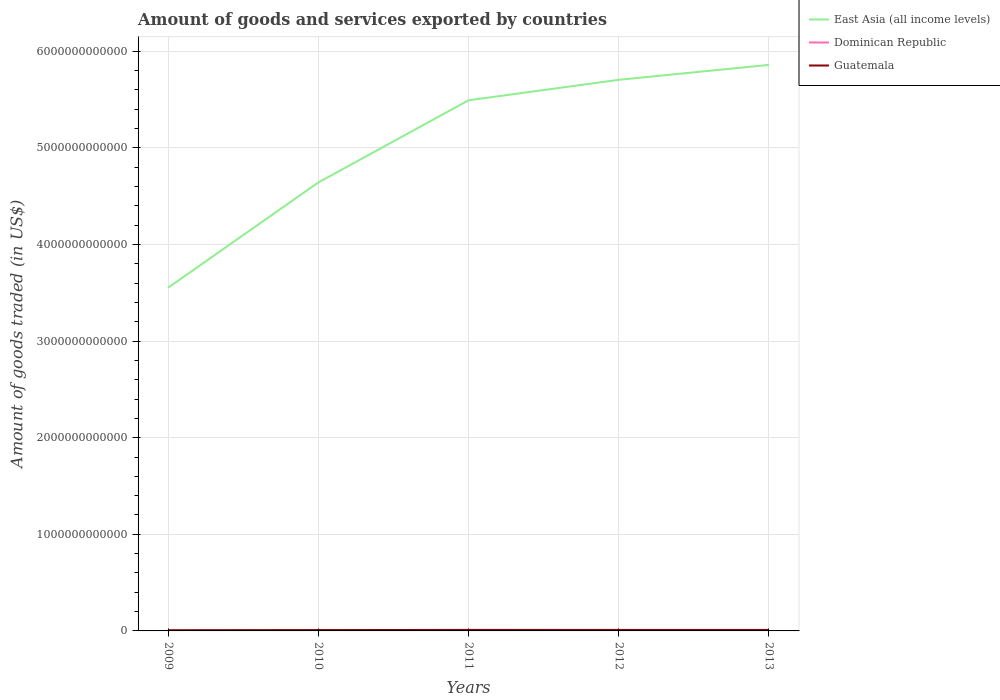Is the number of lines equal to the number of legend labels?
Your answer should be very brief. Yes. Across all years, what is the maximum total amount of goods and services exported in Guatemala?
Ensure brevity in your answer.  7.29e+09. What is the total total amount of goods and services exported in East Asia (all income levels) in the graph?
Keep it short and to the point. -2.31e+12. What is the difference between the highest and the second highest total amount of goods and services exported in East Asia (all income levels)?
Keep it short and to the point. 2.31e+12. How many lines are there?
Offer a terse response. 3. What is the difference between two consecutive major ticks on the Y-axis?
Your response must be concise. 1.00e+12. Does the graph contain grids?
Provide a succinct answer. Yes. How many legend labels are there?
Offer a terse response. 3. What is the title of the graph?
Provide a succinct answer. Amount of goods and services exported by countries. What is the label or title of the X-axis?
Ensure brevity in your answer.  Years. What is the label or title of the Y-axis?
Provide a short and direct response. Amount of goods traded (in US$). What is the Amount of goods traded (in US$) of East Asia (all income levels) in 2009?
Make the answer very short. 3.55e+12. What is the Amount of goods traded (in US$) of Dominican Republic in 2009?
Keep it short and to the point. 1.69e+09. What is the Amount of goods traded (in US$) of Guatemala in 2009?
Make the answer very short. 7.29e+09. What is the Amount of goods traded (in US$) of East Asia (all income levels) in 2010?
Give a very brief answer. 4.64e+12. What is the Amount of goods traded (in US$) in Dominican Republic in 2010?
Your answer should be very brief. 6.81e+09. What is the Amount of goods traded (in US$) in Guatemala in 2010?
Make the answer very short. 8.54e+09. What is the Amount of goods traded (in US$) in East Asia (all income levels) in 2011?
Offer a very short reply. 5.49e+12. What is the Amount of goods traded (in US$) in Dominican Republic in 2011?
Keep it short and to the point. 8.36e+09. What is the Amount of goods traded (in US$) in Guatemala in 2011?
Your answer should be very brief. 1.05e+1. What is the Amount of goods traded (in US$) in East Asia (all income levels) in 2012?
Provide a short and direct response. 5.70e+12. What is the Amount of goods traded (in US$) of Dominican Republic in 2012?
Your answer should be compact. 8.94e+09. What is the Amount of goods traded (in US$) of Guatemala in 2012?
Your answer should be very brief. 1.01e+1. What is the Amount of goods traded (in US$) of East Asia (all income levels) in 2013?
Make the answer very short. 5.86e+12. What is the Amount of goods traded (in US$) in Dominican Republic in 2013?
Your response must be concise. 9.50e+09. What is the Amount of goods traded (in US$) of Guatemala in 2013?
Ensure brevity in your answer.  1.02e+1. Across all years, what is the maximum Amount of goods traded (in US$) of East Asia (all income levels)?
Your answer should be compact. 5.86e+12. Across all years, what is the maximum Amount of goods traded (in US$) in Dominican Republic?
Your response must be concise. 9.50e+09. Across all years, what is the maximum Amount of goods traded (in US$) of Guatemala?
Your answer should be very brief. 1.05e+1. Across all years, what is the minimum Amount of goods traded (in US$) of East Asia (all income levels)?
Ensure brevity in your answer.  3.55e+12. Across all years, what is the minimum Amount of goods traded (in US$) of Dominican Republic?
Provide a short and direct response. 1.69e+09. Across all years, what is the minimum Amount of goods traded (in US$) in Guatemala?
Ensure brevity in your answer.  7.29e+09. What is the total Amount of goods traded (in US$) in East Asia (all income levels) in the graph?
Provide a short and direct response. 2.53e+13. What is the total Amount of goods traded (in US$) of Dominican Republic in the graph?
Your response must be concise. 3.53e+1. What is the total Amount of goods traded (in US$) in Guatemala in the graph?
Offer a very short reply. 4.66e+1. What is the difference between the Amount of goods traded (in US$) of East Asia (all income levels) in 2009 and that in 2010?
Your answer should be compact. -1.09e+12. What is the difference between the Amount of goods traded (in US$) of Dominican Republic in 2009 and that in 2010?
Provide a succinct answer. -5.13e+09. What is the difference between the Amount of goods traded (in US$) in Guatemala in 2009 and that in 2010?
Provide a succinct answer. -1.24e+09. What is the difference between the Amount of goods traded (in US$) of East Asia (all income levels) in 2009 and that in 2011?
Your answer should be compact. -1.94e+12. What is the difference between the Amount of goods traded (in US$) of Dominican Republic in 2009 and that in 2011?
Your answer should be compact. -6.67e+09. What is the difference between the Amount of goods traded (in US$) in Guatemala in 2009 and that in 2011?
Provide a succinct answer. -3.22e+09. What is the difference between the Amount of goods traded (in US$) in East Asia (all income levels) in 2009 and that in 2012?
Provide a short and direct response. -2.15e+12. What is the difference between the Amount of goods traded (in US$) of Dominican Republic in 2009 and that in 2012?
Keep it short and to the point. -7.25e+09. What is the difference between the Amount of goods traded (in US$) in Guatemala in 2009 and that in 2012?
Provide a succinct answer. -2.81e+09. What is the difference between the Amount of goods traded (in US$) of East Asia (all income levels) in 2009 and that in 2013?
Offer a very short reply. -2.31e+12. What is the difference between the Amount of goods traded (in US$) in Dominican Republic in 2009 and that in 2013?
Give a very brief answer. -7.81e+09. What is the difference between the Amount of goods traded (in US$) of Guatemala in 2009 and that in 2013?
Your answer should be compact. -2.89e+09. What is the difference between the Amount of goods traded (in US$) in East Asia (all income levels) in 2010 and that in 2011?
Your response must be concise. -8.50e+11. What is the difference between the Amount of goods traded (in US$) in Dominican Republic in 2010 and that in 2011?
Your answer should be compact. -1.55e+09. What is the difference between the Amount of goods traded (in US$) of Guatemala in 2010 and that in 2011?
Your answer should be compact. -1.98e+09. What is the difference between the Amount of goods traded (in US$) in East Asia (all income levels) in 2010 and that in 2012?
Offer a terse response. -1.06e+12. What is the difference between the Amount of goods traded (in US$) in Dominican Republic in 2010 and that in 2012?
Keep it short and to the point. -2.12e+09. What is the difference between the Amount of goods traded (in US$) of Guatemala in 2010 and that in 2012?
Ensure brevity in your answer.  -1.57e+09. What is the difference between the Amount of goods traded (in US$) of East Asia (all income levels) in 2010 and that in 2013?
Offer a very short reply. -1.22e+12. What is the difference between the Amount of goods traded (in US$) of Dominican Republic in 2010 and that in 2013?
Offer a terse response. -2.69e+09. What is the difference between the Amount of goods traded (in US$) of Guatemala in 2010 and that in 2013?
Your answer should be compact. -1.65e+09. What is the difference between the Amount of goods traded (in US$) of East Asia (all income levels) in 2011 and that in 2012?
Offer a very short reply. -2.12e+11. What is the difference between the Amount of goods traded (in US$) of Dominican Republic in 2011 and that in 2012?
Provide a succinct answer. -5.74e+08. What is the difference between the Amount of goods traded (in US$) in Guatemala in 2011 and that in 2012?
Offer a very short reply. 4.16e+08. What is the difference between the Amount of goods traded (in US$) of East Asia (all income levels) in 2011 and that in 2013?
Your answer should be very brief. -3.66e+11. What is the difference between the Amount of goods traded (in US$) of Dominican Republic in 2011 and that in 2013?
Offer a very short reply. -1.14e+09. What is the difference between the Amount of goods traded (in US$) in Guatemala in 2011 and that in 2013?
Ensure brevity in your answer.  3.36e+08. What is the difference between the Amount of goods traded (in US$) in East Asia (all income levels) in 2012 and that in 2013?
Offer a very short reply. -1.55e+11. What is the difference between the Amount of goods traded (in US$) in Dominican Republic in 2012 and that in 2013?
Your answer should be compact. -5.68e+08. What is the difference between the Amount of goods traded (in US$) of Guatemala in 2012 and that in 2013?
Give a very brief answer. -7.99e+07. What is the difference between the Amount of goods traded (in US$) of East Asia (all income levels) in 2009 and the Amount of goods traded (in US$) of Dominican Republic in 2010?
Keep it short and to the point. 3.55e+12. What is the difference between the Amount of goods traded (in US$) of East Asia (all income levels) in 2009 and the Amount of goods traded (in US$) of Guatemala in 2010?
Your answer should be very brief. 3.55e+12. What is the difference between the Amount of goods traded (in US$) in Dominican Republic in 2009 and the Amount of goods traded (in US$) in Guatemala in 2010?
Ensure brevity in your answer.  -6.85e+09. What is the difference between the Amount of goods traded (in US$) in East Asia (all income levels) in 2009 and the Amount of goods traded (in US$) in Dominican Republic in 2011?
Make the answer very short. 3.55e+12. What is the difference between the Amount of goods traded (in US$) in East Asia (all income levels) in 2009 and the Amount of goods traded (in US$) in Guatemala in 2011?
Provide a short and direct response. 3.54e+12. What is the difference between the Amount of goods traded (in US$) of Dominican Republic in 2009 and the Amount of goods traded (in US$) of Guatemala in 2011?
Your answer should be very brief. -8.83e+09. What is the difference between the Amount of goods traded (in US$) in East Asia (all income levels) in 2009 and the Amount of goods traded (in US$) in Dominican Republic in 2012?
Offer a terse response. 3.54e+12. What is the difference between the Amount of goods traded (in US$) of East Asia (all income levels) in 2009 and the Amount of goods traded (in US$) of Guatemala in 2012?
Your answer should be very brief. 3.54e+12. What is the difference between the Amount of goods traded (in US$) of Dominican Republic in 2009 and the Amount of goods traded (in US$) of Guatemala in 2012?
Provide a succinct answer. -8.41e+09. What is the difference between the Amount of goods traded (in US$) in East Asia (all income levels) in 2009 and the Amount of goods traded (in US$) in Dominican Republic in 2013?
Provide a succinct answer. 3.54e+12. What is the difference between the Amount of goods traded (in US$) in East Asia (all income levels) in 2009 and the Amount of goods traded (in US$) in Guatemala in 2013?
Offer a very short reply. 3.54e+12. What is the difference between the Amount of goods traded (in US$) in Dominican Republic in 2009 and the Amount of goods traded (in US$) in Guatemala in 2013?
Offer a very short reply. -8.49e+09. What is the difference between the Amount of goods traded (in US$) in East Asia (all income levels) in 2010 and the Amount of goods traded (in US$) in Dominican Republic in 2011?
Ensure brevity in your answer.  4.63e+12. What is the difference between the Amount of goods traded (in US$) of East Asia (all income levels) in 2010 and the Amount of goods traded (in US$) of Guatemala in 2011?
Give a very brief answer. 4.63e+12. What is the difference between the Amount of goods traded (in US$) of Dominican Republic in 2010 and the Amount of goods traded (in US$) of Guatemala in 2011?
Offer a terse response. -3.70e+09. What is the difference between the Amount of goods traded (in US$) in East Asia (all income levels) in 2010 and the Amount of goods traded (in US$) in Dominican Republic in 2012?
Ensure brevity in your answer.  4.63e+12. What is the difference between the Amount of goods traded (in US$) in East Asia (all income levels) in 2010 and the Amount of goods traded (in US$) in Guatemala in 2012?
Provide a short and direct response. 4.63e+12. What is the difference between the Amount of goods traded (in US$) in Dominican Republic in 2010 and the Amount of goods traded (in US$) in Guatemala in 2012?
Keep it short and to the point. -3.29e+09. What is the difference between the Amount of goods traded (in US$) in East Asia (all income levels) in 2010 and the Amount of goods traded (in US$) in Dominican Republic in 2013?
Your answer should be very brief. 4.63e+12. What is the difference between the Amount of goods traded (in US$) of East Asia (all income levels) in 2010 and the Amount of goods traded (in US$) of Guatemala in 2013?
Provide a succinct answer. 4.63e+12. What is the difference between the Amount of goods traded (in US$) of Dominican Republic in 2010 and the Amount of goods traded (in US$) of Guatemala in 2013?
Ensure brevity in your answer.  -3.37e+09. What is the difference between the Amount of goods traded (in US$) in East Asia (all income levels) in 2011 and the Amount of goods traded (in US$) in Dominican Republic in 2012?
Your answer should be very brief. 5.48e+12. What is the difference between the Amount of goods traded (in US$) of East Asia (all income levels) in 2011 and the Amount of goods traded (in US$) of Guatemala in 2012?
Ensure brevity in your answer.  5.48e+12. What is the difference between the Amount of goods traded (in US$) in Dominican Republic in 2011 and the Amount of goods traded (in US$) in Guatemala in 2012?
Provide a short and direct response. -1.74e+09. What is the difference between the Amount of goods traded (in US$) of East Asia (all income levels) in 2011 and the Amount of goods traded (in US$) of Dominican Republic in 2013?
Make the answer very short. 5.48e+12. What is the difference between the Amount of goods traded (in US$) of East Asia (all income levels) in 2011 and the Amount of goods traded (in US$) of Guatemala in 2013?
Ensure brevity in your answer.  5.48e+12. What is the difference between the Amount of goods traded (in US$) of Dominican Republic in 2011 and the Amount of goods traded (in US$) of Guatemala in 2013?
Provide a succinct answer. -1.82e+09. What is the difference between the Amount of goods traded (in US$) in East Asia (all income levels) in 2012 and the Amount of goods traded (in US$) in Dominican Republic in 2013?
Offer a very short reply. 5.69e+12. What is the difference between the Amount of goods traded (in US$) of East Asia (all income levels) in 2012 and the Amount of goods traded (in US$) of Guatemala in 2013?
Provide a short and direct response. 5.69e+12. What is the difference between the Amount of goods traded (in US$) in Dominican Republic in 2012 and the Amount of goods traded (in US$) in Guatemala in 2013?
Offer a very short reply. -1.25e+09. What is the average Amount of goods traded (in US$) in East Asia (all income levels) per year?
Ensure brevity in your answer.  5.05e+12. What is the average Amount of goods traded (in US$) in Dominican Republic per year?
Your response must be concise. 7.06e+09. What is the average Amount of goods traded (in US$) of Guatemala per year?
Make the answer very short. 9.33e+09. In the year 2009, what is the difference between the Amount of goods traded (in US$) of East Asia (all income levels) and Amount of goods traded (in US$) of Dominican Republic?
Offer a terse response. 3.55e+12. In the year 2009, what is the difference between the Amount of goods traded (in US$) of East Asia (all income levels) and Amount of goods traded (in US$) of Guatemala?
Give a very brief answer. 3.55e+12. In the year 2009, what is the difference between the Amount of goods traded (in US$) of Dominican Republic and Amount of goods traded (in US$) of Guatemala?
Your answer should be compact. -5.61e+09. In the year 2010, what is the difference between the Amount of goods traded (in US$) of East Asia (all income levels) and Amount of goods traded (in US$) of Dominican Republic?
Your response must be concise. 4.64e+12. In the year 2010, what is the difference between the Amount of goods traded (in US$) of East Asia (all income levels) and Amount of goods traded (in US$) of Guatemala?
Ensure brevity in your answer.  4.63e+12. In the year 2010, what is the difference between the Amount of goods traded (in US$) in Dominican Republic and Amount of goods traded (in US$) in Guatemala?
Ensure brevity in your answer.  -1.72e+09. In the year 2011, what is the difference between the Amount of goods traded (in US$) of East Asia (all income levels) and Amount of goods traded (in US$) of Dominican Republic?
Keep it short and to the point. 5.48e+12. In the year 2011, what is the difference between the Amount of goods traded (in US$) in East Asia (all income levels) and Amount of goods traded (in US$) in Guatemala?
Keep it short and to the point. 5.48e+12. In the year 2011, what is the difference between the Amount of goods traded (in US$) of Dominican Republic and Amount of goods traded (in US$) of Guatemala?
Make the answer very short. -2.16e+09. In the year 2012, what is the difference between the Amount of goods traded (in US$) in East Asia (all income levels) and Amount of goods traded (in US$) in Dominican Republic?
Your response must be concise. 5.70e+12. In the year 2012, what is the difference between the Amount of goods traded (in US$) of East Asia (all income levels) and Amount of goods traded (in US$) of Guatemala?
Offer a very short reply. 5.69e+12. In the year 2012, what is the difference between the Amount of goods traded (in US$) in Dominican Republic and Amount of goods traded (in US$) in Guatemala?
Offer a very short reply. -1.17e+09. In the year 2013, what is the difference between the Amount of goods traded (in US$) of East Asia (all income levels) and Amount of goods traded (in US$) of Dominican Republic?
Provide a short and direct response. 5.85e+12. In the year 2013, what is the difference between the Amount of goods traded (in US$) in East Asia (all income levels) and Amount of goods traded (in US$) in Guatemala?
Give a very brief answer. 5.85e+12. In the year 2013, what is the difference between the Amount of goods traded (in US$) of Dominican Republic and Amount of goods traded (in US$) of Guatemala?
Provide a short and direct response. -6.79e+08. What is the ratio of the Amount of goods traded (in US$) of East Asia (all income levels) in 2009 to that in 2010?
Ensure brevity in your answer.  0.77. What is the ratio of the Amount of goods traded (in US$) of Dominican Republic in 2009 to that in 2010?
Make the answer very short. 0.25. What is the ratio of the Amount of goods traded (in US$) of Guatemala in 2009 to that in 2010?
Make the answer very short. 0.85. What is the ratio of the Amount of goods traded (in US$) in East Asia (all income levels) in 2009 to that in 2011?
Keep it short and to the point. 0.65. What is the ratio of the Amount of goods traded (in US$) in Dominican Republic in 2009 to that in 2011?
Make the answer very short. 0.2. What is the ratio of the Amount of goods traded (in US$) in Guatemala in 2009 to that in 2011?
Provide a short and direct response. 0.69. What is the ratio of the Amount of goods traded (in US$) in East Asia (all income levels) in 2009 to that in 2012?
Give a very brief answer. 0.62. What is the ratio of the Amount of goods traded (in US$) of Dominican Republic in 2009 to that in 2012?
Your answer should be very brief. 0.19. What is the ratio of the Amount of goods traded (in US$) of Guatemala in 2009 to that in 2012?
Give a very brief answer. 0.72. What is the ratio of the Amount of goods traded (in US$) in East Asia (all income levels) in 2009 to that in 2013?
Your response must be concise. 0.61. What is the ratio of the Amount of goods traded (in US$) of Dominican Republic in 2009 to that in 2013?
Provide a succinct answer. 0.18. What is the ratio of the Amount of goods traded (in US$) of Guatemala in 2009 to that in 2013?
Your answer should be compact. 0.72. What is the ratio of the Amount of goods traded (in US$) of East Asia (all income levels) in 2010 to that in 2011?
Provide a short and direct response. 0.85. What is the ratio of the Amount of goods traded (in US$) of Dominican Republic in 2010 to that in 2011?
Ensure brevity in your answer.  0.81. What is the ratio of the Amount of goods traded (in US$) of Guatemala in 2010 to that in 2011?
Your answer should be very brief. 0.81. What is the ratio of the Amount of goods traded (in US$) in East Asia (all income levels) in 2010 to that in 2012?
Keep it short and to the point. 0.81. What is the ratio of the Amount of goods traded (in US$) of Dominican Republic in 2010 to that in 2012?
Your response must be concise. 0.76. What is the ratio of the Amount of goods traded (in US$) in Guatemala in 2010 to that in 2012?
Give a very brief answer. 0.84. What is the ratio of the Amount of goods traded (in US$) in East Asia (all income levels) in 2010 to that in 2013?
Your answer should be compact. 0.79. What is the ratio of the Amount of goods traded (in US$) of Dominican Republic in 2010 to that in 2013?
Your answer should be very brief. 0.72. What is the ratio of the Amount of goods traded (in US$) of Guatemala in 2010 to that in 2013?
Offer a terse response. 0.84. What is the ratio of the Amount of goods traded (in US$) in East Asia (all income levels) in 2011 to that in 2012?
Offer a very short reply. 0.96. What is the ratio of the Amount of goods traded (in US$) of Dominican Republic in 2011 to that in 2012?
Give a very brief answer. 0.94. What is the ratio of the Amount of goods traded (in US$) in Guatemala in 2011 to that in 2012?
Make the answer very short. 1.04. What is the ratio of the Amount of goods traded (in US$) in Dominican Republic in 2011 to that in 2013?
Your response must be concise. 0.88. What is the ratio of the Amount of goods traded (in US$) in Guatemala in 2011 to that in 2013?
Your response must be concise. 1.03. What is the ratio of the Amount of goods traded (in US$) of East Asia (all income levels) in 2012 to that in 2013?
Offer a very short reply. 0.97. What is the ratio of the Amount of goods traded (in US$) of Dominican Republic in 2012 to that in 2013?
Provide a short and direct response. 0.94. What is the ratio of the Amount of goods traded (in US$) of Guatemala in 2012 to that in 2013?
Provide a succinct answer. 0.99. What is the difference between the highest and the second highest Amount of goods traded (in US$) of East Asia (all income levels)?
Your response must be concise. 1.55e+11. What is the difference between the highest and the second highest Amount of goods traded (in US$) in Dominican Republic?
Offer a terse response. 5.68e+08. What is the difference between the highest and the second highest Amount of goods traded (in US$) of Guatemala?
Offer a very short reply. 3.36e+08. What is the difference between the highest and the lowest Amount of goods traded (in US$) in East Asia (all income levels)?
Keep it short and to the point. 2.31e+12. What is the difference between the highest and the lowest Amount of goods traded (in US$) of Dominican Republic?
Give a very brief answer. 7.81e+09. What is the difference between the highest and the lowest Amount of goods traded (in US$) of Guatemala?
Your answer should be compact. 3.22e+09. 